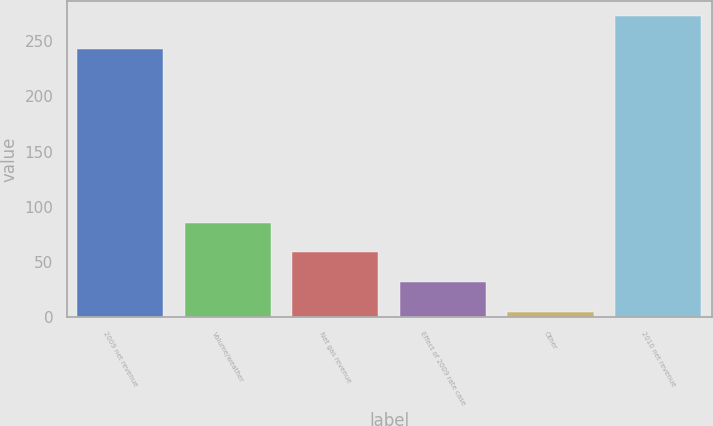Convert chart. <chart><loc_0><loc_0><loc_500><loc_500><bar_chart><fcel>2009 net revenue<fcel>Volume/weather<fcel>Net gas revenue<fcel>Effect of 2009 rate case<fcel>Other<fcel>2010 net revenue<nl><fcel>243<fcel>85.58<fcel>58.82<fcel>32.06<fcel>5.3<fcel>272.9<nl></chart> 